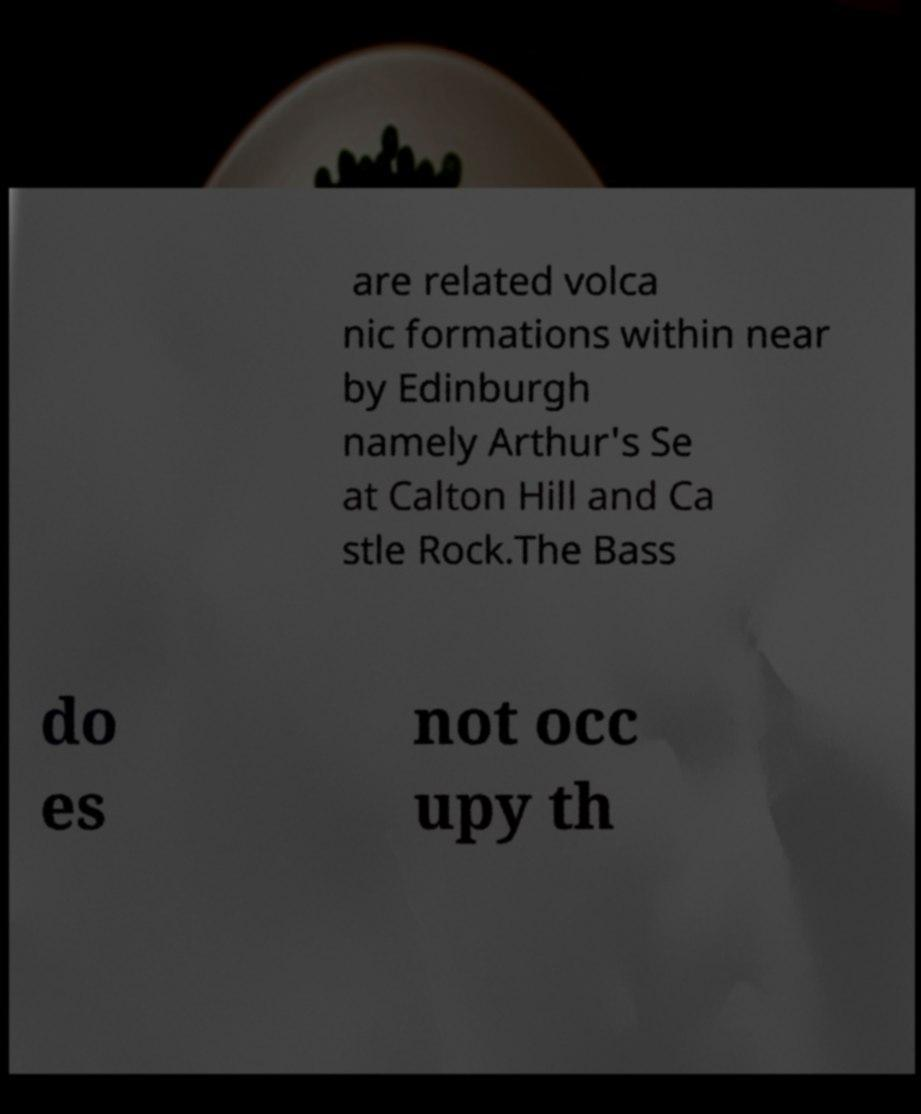There's text embedded in this image that I need extracted. Can you transcribe it verbatim? are related volca nic formations within near by Edinburgh namely Arthur's Se at Calton Hill and Ca stle Rock.The Bass do es not occ upy th 